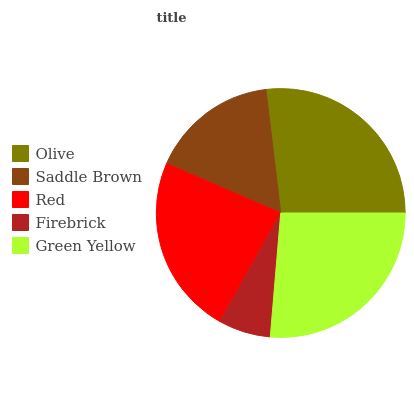Is Firebrick the minimum?
Answer yes or no. Yes. Is Olive the maximum?
Answer yes or no. Yes. Is Saddle Brown the minimum?
Answer yes or no. No. Is Saddle Brown the maximum?
Answer yes or no. No. Is Olive greater than Saddle Brown?
Answer yes or no. Yes. Is Saddle Brown less than Olive?
Answer yes or no. Yes. Is Saddle Brown greater than Olive?
Answer yes or no. No. Is Olive less than Saddle Brown?
Answer yes or no. No. Is Red the high median?
Answer yes or no. Yes. Is Red the low median?
Answer yes or no. Yes. Is Green Yellow the high median?
Answer yes or no. No. Is Olive the low median?
Answer yes or no. No. 